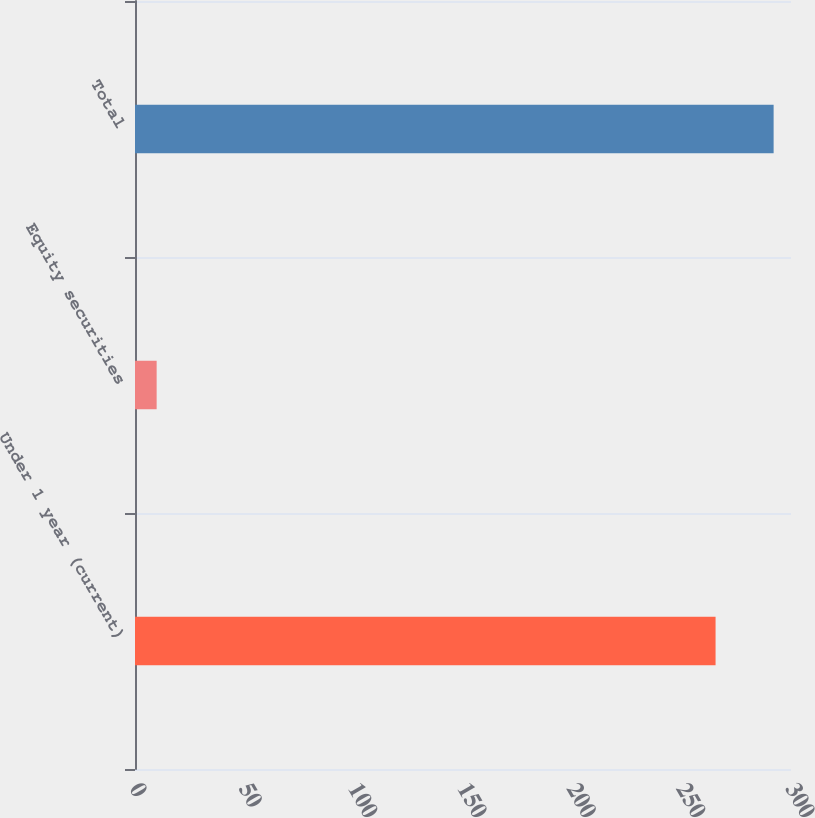Convert chart to OTSL. <chart><loc_0><loc_0><loc_500><loc_500><bar_chart><fcel>Under 1 year (current)<fcel>Equity securities<fcel>Total<nl><fcel>265.5<fcel>9.9<fcel>292.05<nl></chart> 